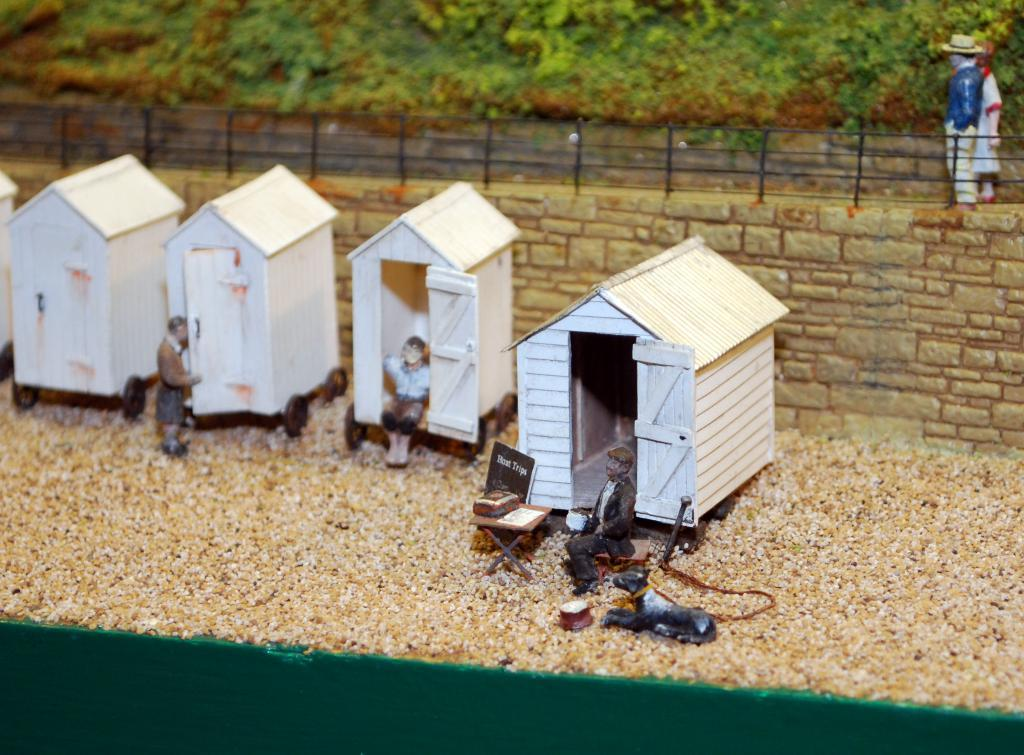What type of animals are in the image? There are miniature horses in the image. What other objects or figures can be seen in the image? There are dolls in the image. What can be seen in the background of the image? There is a wall, fencing, plants, and grass in the background of the image. What type of pancake is being served to the miniature horses in the image? There is no pancake present in the image; it features miniature horses and dolls. What type of work are the miniature horses doing in the image? The image does not depict the miniature horses performing any work; they are simply present in the scene. 